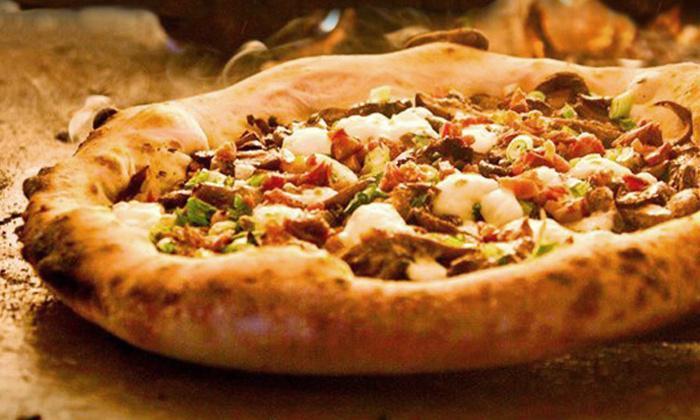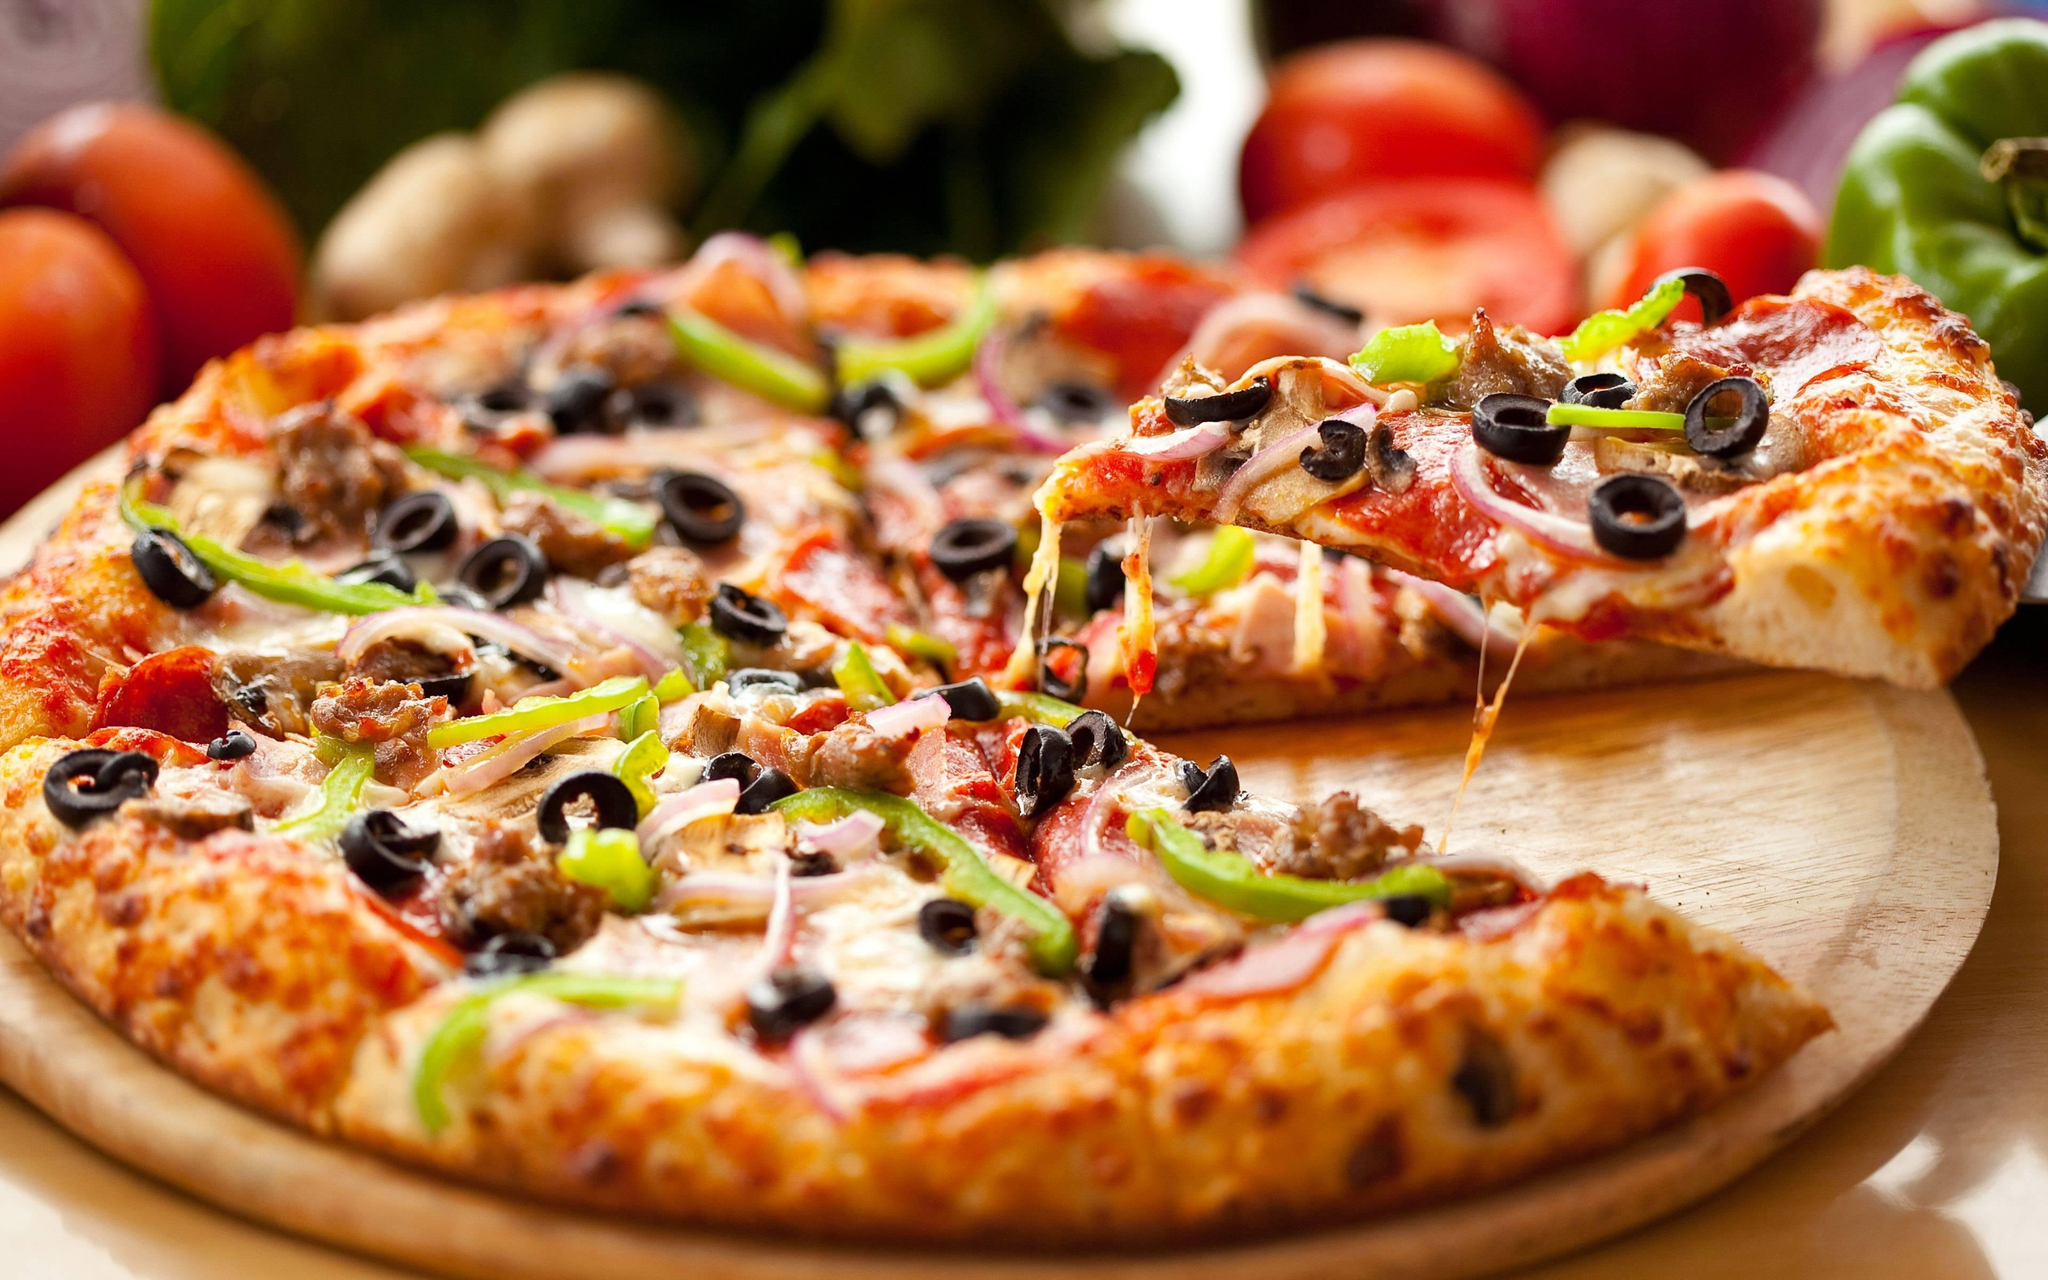The first image is the image on the left, the second image is the image on the right. For the images displayed, is the sentence "The left image shows a pizza that is sliced but no slices are missing, and the right image shows a plate with some slices on it." factually correct? Answer yes or no. No. The first image is the image on the left, the second image is the image on the right. Considering the images on both sides, is "At least one straw is visible in the right image." valid? Answer yes or no. No. 